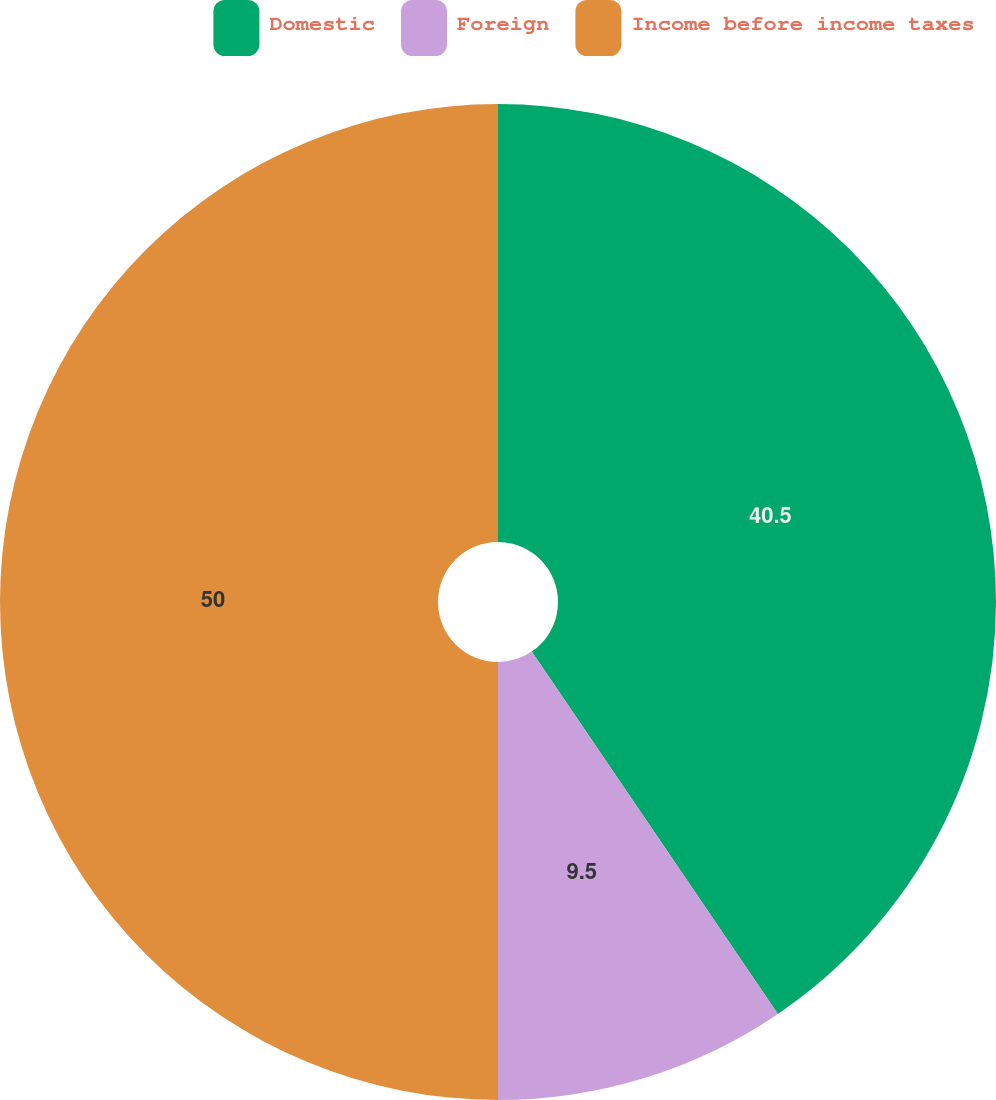Convert chart to OTSL. <chart><loc_0><loc_0><loc_500><loc_500><pie_chart><fcel>Domestic<fcel>Foreign<fcel>Income before income taxes<nl><fcel>40.5%<fcel>9.5%<fcel>50.0%<nl></chart> 